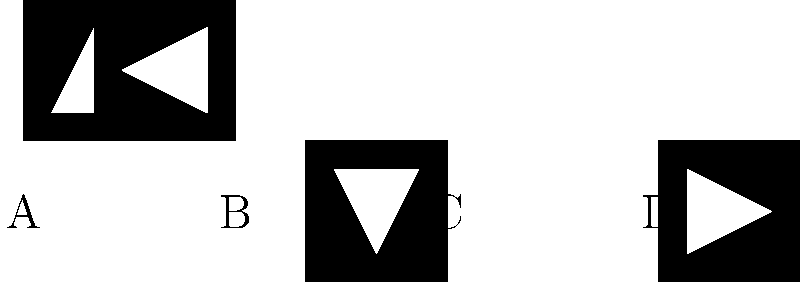As an aspiring TikToker, you're designing a new logo for your profile. The logo consists of a black square with a white musical note inside. Which of the options A, B, C, or D shows the correct orientation of the logo if you want the musical note to point upwards? To solve this puzzle, we need to analyze each option and determine which one has the musical note pointing upwards:

1. Option A: The musical note is pointing to the right.
2. Option B: The musical note is pointing upwards.
3. Option C: The musical note is pointing to the left.
4. Option D: The musical note is pointing downwards.

Since we want the musical note to point upwards, option B is the correct choice. This orientation would be ideal for a TikTok profile logo, as it clearly displays the musical theme, which is central to the platform's content.
Answer: B 